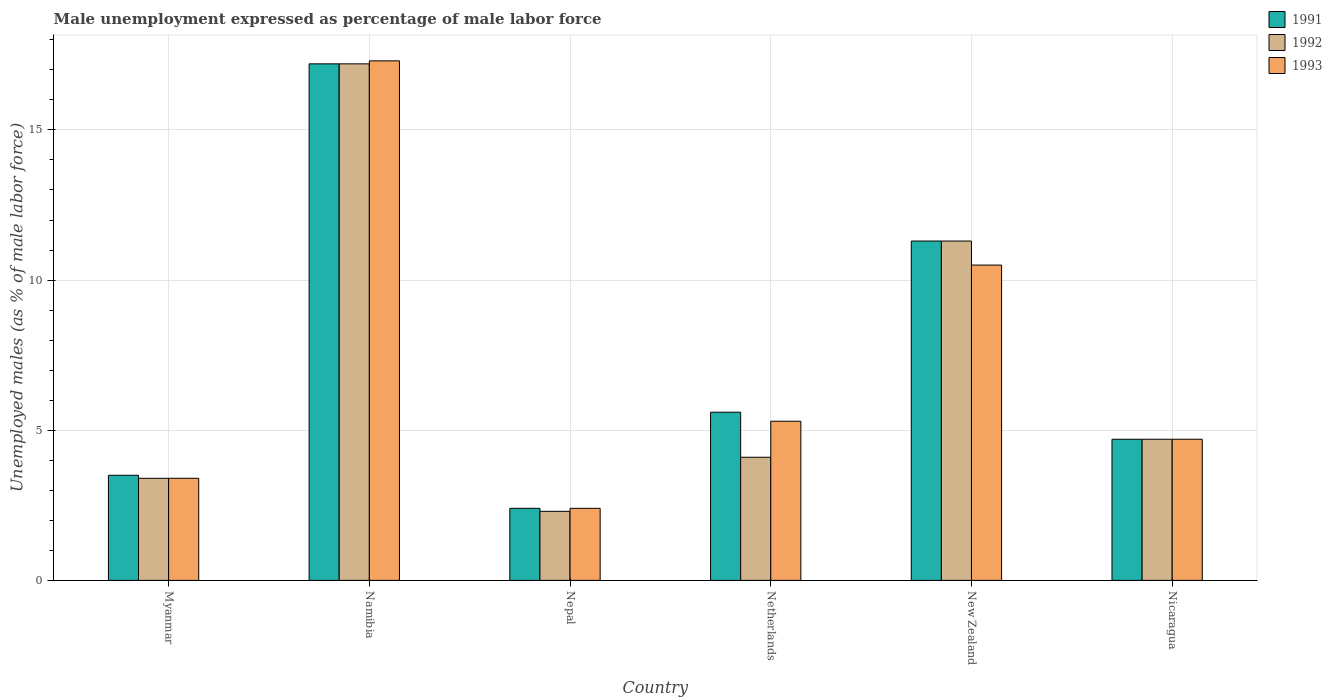How many different coloured bars are there?
Your answer should be compact. 3. How many groups of bars are there?
Ensure brevity in your answer.  6. Are the number of bars per tick equal to the number of legend labels?
Your response must be concise. Yes. Are the number of bars on each tick of the X-axis equal?
Offer a very short reply. Yes. How many bars are there on the 6th tick from the left?
Your answer should be very brief. 3. How many bars are there on the 4th tick from the right?
Provide a short and direct response. 3. What is the label of the 5th group of bars from the left?
Offer a terse response. New Zealand. In how many cases, is the number of bars for a given country not equal to the number of legend labels?
Your answer should be compact. 0. What is the unemployment in males in in 1992 in New Zealand?
Offer a terse response. 11.3. Across all countries, what is the maximum unemployment in males in in 1991?
Your answer should be very brief. 17.2. Across all countries, what is the minimum unemployment in males in in 1993?
Your response must be concise. 2.4. In which country was the unemployment in males in in 1993 maximum?
Ensure brevity in your answer.  Namibia. In which country was the unemployment in males in in 1992 minimum?
Make the answer very short. Nepal. What is the total unemployment in males in in 1992 in the graph?
Your answer should be very brief. 43. What is the difference between the unemployment in males in in 1993 in Myanmar and that in Nicaragua?
Ensure brevity in your answer.  -1.3. What is the difference between the unemployment in males in in 1991 in New Zealand and the unemployment in males in in 1993 in Netherlands?
Your response must be concise. 6. What is the average unemployment in males in in 1992 per country?
Your answer should be compact. 7.17. What is the difference between the unemployment in males in of/in 1992 and unemployment in males in of/in 1991 in Netherlands?
Offer a terse response. -1.5. What is the ratio of the unemployment in males in in 1992 in Myanmar to that in Netherlands?
Offer a terse response. 0.83. Is the difference between the unemployment in males in in 1992 in Namibia and Nicaragua greater than the difference between the unemployment in males in in 1991 in Namibia and Nicaragua?
Your response must be concise. No. What is the difference between the highest and the second highest unemployment in males in in 1993?
Your answer should be very brief. 6.8. What is the difference between the highest and the lowest unemployment in males in in 1992?
Keep it short and to the point. 14.9. Is the sum of the unemployment in males in in 1991 in New Zealand and Nicaragua greater than the maximum unemployment in males in in 1993 across all countries?
Give a very brief answer. No. What does the 2nd bar from the left in Nepal represents?
Ensure brevity in your answer.  1992. Is it the case that in every country, the sum of the unemployment in males in in 1991 and unemployment in males in in 1992 is greater than the unemployment in males in in 1993?
Your answer should be very brief. Yes. Are all the bars in the graph horizontal?
Offer a terse response. No. How many countries are there in the graph?
Ensure brevity in your answer.  6. What is the difference between two consecutive major ticks on the Y-axis?
Offer a very short reply. 5. Are the values on the major ticks of Y-axis written in scientific E-notation?
Offer a very short reply. No. How many legend labels are there?
Make the answer very short. 3. What is the title of the graph?
Make the answer very short. Male unemployment expressed as percentage of male labor force. Does "1963" appear as one of the legend labels in the graph?
Offer a terse response. No. What is the label or title of the X-axis?
Offer a terse response. Country. What is the label or title of the Y-axis?
Offer a very short reply. Unemployed males (as % of male labor force). What is the Unemployed males (as % of male labor force) of 1992 in Myanmar?
Your answer should be compact. 3.4. What is the Unemployed males (as % of male labor force) of 1993 in Myanmar?
Keep it short and to the point. 3.4. What is the Unemployed males (as % of male labor force) in 1991 in Namibia?
Keep it short and to the point. 17.2. What is the Unemployed males (as % of male labor force) of 1992 in Namibia?
Your answer should be very brief. 17.2. What is the Unemployed males (as % of male labor force) in 1993 in Namibia?
Make the answer very short. 17.3. What is the Unemployed males (as % of male labor force) of 1991 in Nepal?
Keep it short and to the point. 2.4. What is the Unemployed males (as % of male labor force) of 1992 in Nepal?
Ensure brevity in your answer.  2.3. What is the Unemployed males (as % of male labor force) of 1993 in Nepal?
Your answer should be compact. 2.4. What is the Unemployed males (as % of male labor force) in 1991 in Netherlands?
Offer a very short reply. 5.6. What is the Unemployed males (as % of male labor force) of 1992 in Netherlands?
Provide a succinct answer. 4.1. What is the Unemployed males (as % of male labor force) of 1993 in Netherlands?
Offer a terse response. 5.3. What is the Unemployed males (as % of male labor force) in 1991 in New Zealand?
Provide a short and direct response. 11.3. What is the Unemployed males (as % of male labor force) of 1992 in New Zealand?
Provide a succinct answer. 11.3. What is the Unemployed males (as % of male labor force) in 1993 in New Zealand?
Make the answer very short. 10.5. What is the Unemployed males (as % of male labor force) in 1991 in Nicaragua?
Offer a terse response. 4.7. What is the Unemployed males (as % of male labor force) of 1992 in Nicaragua?
Your answer should be very brief. 4.7. What is the Unemployed males (as % of male labor force) in 1993 in Nicaragua?
Keep it short and to the point. 4.7. Across all countries, what is the maximum Unemployed males (as % of male labor force) of 1991?
Make the answer very short. 17.2. Across all countries, what is the maximum Unemployed males (as % of male labor force) of 1992?
Give a very brief answer. 17.2. Across all countries, what is the maximum Unemployed males (as % of male labor force) in 1993?
Make the answer very short. 17.3. Across all countries, what is the minimum Unemployed males (as % of male labor force) of 1991?
Make the answer very short. 2.4. Across all countries, what is the minimum Unemployed males (as % of male labor force) in 1992?
Your answer should be compact. 2.3. Across all countries, what is the minimum Unemployed males (as % of male labor force) in 1993?
Provide a succinct answer. 2.4. What is the total Unemployed males (as % of male labor force) of 1991 in the graph?
Offer a terse response. 44.7. What is the total Unemployed males (as % of male labor force) in 1992 in the graph?
Make the answer very short. 43. What is the total Unemployed males (as % of male labor force) in 1993 in the graph?
Provide a short and direct response. 43.6. What is the difference between the Unemployed males (as % of male labor force) in 1991 in Myanmar and that in Namibia?
Give a very brief answer. -13.7. What is the difference between the Unemployed males (as % of male labor force) of 1992 in Myanmar and that in Namibia?
Your response must be concise. -13.8. What is the difference between the Unemployed males (as % of male labor force) of 1992 in Myanmar and that in Nepal?
Your answer should be compact. 1.1. What is the difference between the Unemployed males (as % of male labor force) in 1991 in Myanmar and that in Netherlands?
Your response must be concise. -2.1. What is the difference between the Unemployed males (as % of male labor force) of 1992 in Myanmar and that in Netherlands?
Offer a very short reply. -0.7. What is the difference between the Unemployed males (as % of male labor force) of 1991 in Myanmar and that in New Zealand?
Offer a terse response. -7.8. What is the difference between the Unemployed males (as % of male labor force) in 1992 in Myanmar and that in New Zealand?
Offer a terse response. -7.9. What is the difference between the Unemployed males (as % of male labor force) in 1993 in Myanmar and that in Nicaragua?
Your response must be concise. -1.3. What is the difference between the Unemployed males (as % of male labor force) in 1993 in Namibia and that in Nepal?
Your answer should be compact. 14.9. What is the difference between the Unemployed males (as % of male labor force) of 1992 in Namibia and that in Netherlands?
Offer a terse response. 13.1. What is the difference between the Unemployed males (as % of male labor force) of 1991 in Namibia and that in Nicaragua?
Make the answer very short. 12.5. What is the difference between the Unemployed males (as % of male labor force) of 1991 in Nepal and that in Netherlands?
Provide a succinct answer. -3.2. What is the difference between the Unemployed males (as % of male labor force) of 1992 in Nepal and that in Netherlands?
Offer a very short reply. -1.8. What is the difference between the Unemployed males (as % of male labor force) in 1993 in Nepal and that in Netherlands?
Your response must be concise. -2.9. What is the difference between the Unemployed males (as % of male labor force) in 1991 in Nepal and that in New Zealand?
Make the answer very short. -8.9. What is the difference between the Unemployed males (as % of male labor force) in 1991 in Nepal and that in Nicaragua?
Your answer should be very brief. -2.3. What is the difference between the Unemployed males (as % of male labor force) of 1992 in Nepal and that in Nicaragua?
Your answer should be very brief. -2.4. What is the difference between the Unemployed males (as % of male labor force) of 1992 in Netherlands and that in New Zealand?
Offer a terse response. -7.2. What is the difference between the Unemployed males (as % of male labor force) in 1993 in Netherlands and that in Nicaragua?
Your answer should be very brief. 0.6. What is the difference between the Unemployed males (as % of male labor force) in 1992 in New Zealand and that in Nicaragua?
Provide a short and direct response. 6.6. What is the difference between the Unemployed males (as % of male labor force) in 1991 in Myanmar and the Unemployed males (as % of male labor force) in 1992 in Namibia?
Provide a succinct answer. -13.7. What is the difference between the Unemployed males (as % of male labor force) of 1991 in Myanmar and the Unemployed males (as % of male labor force) of 1992 in Nepal?
Keep it short and to the point. 1.2. What is the difference between the Unemployed males (as % of male labor force) of 1991 in Myanmar and the Unemployed males (as % of male labor force) of 1993 in Nepal?
Keep it short and to the point. 1.1. What is the difference between the Unemployed males (as % of male labor force) of 1991 in Myanmar and the Unemployed males (as % of male labor force) of 1992 in Netherlands?
Your response must be concise. -0.6. What is the difference between the Unemployed males (as % of male labor force) in 1992 in Myanmar and the Unemployed males (as % of male labor force) in 1993 in Netherlands?
Provide a succinct answer. -1.9. What is the difference between the Unemployed males (as % of male labor force) in 1991 in Myanmar and the Unemployed males (as % of male labor force) in 1992 in New Zealand?
Give a very brief answer. -7.8. What is the difference between the Unemployed males (as % of male labor force) of 1992 in Myanmar and the Unemployed males (as % of male labor force) of 1993 in Nicaragua?
Provide a succinct answer. -1.3. What is the difference between the Unemployed males (as % of male labor force) of 1991 in Namibia and the Unemployed males (as % of male labor force) of 1992 in Nepal?
Provide a short and direct response. 14.9. What is the difference between the Unemployed males (as % of male labor force) of 1991 in Namibia and the Unemployed males (as % of male labor force) of 1993 in Netherlands?
Provide a succinct answer. 11.9. What is the difference between the Unemployed males (as % of male labor force) in 1992 in Namibia and the Unemployed males (as % of male labor force) in 1993 in Netherlands?
Offer a terse response. 11.9. What is the difference between the Unemployed males (as % of male labor force) of 1991 in Namibia and the Unemployed males (as % of male labor force) of 1992 in New Zealand?
Offer a terse response. 5.9. What is the difference between the Unemployed males (as % of male labor force) of 1991 in Namibia and the Unemployed males (as % of male labor force) of 1993 in New Zealand?
Keep it short and to the point. 6.7. What is the difference between the Unemployed males (as % of male labor force) of 1991 in Namibia and the Unemployed males (as % of male labor force) of 1992 in Nicaragua?
Offer a terse response. 12.5. What is the difference between the Unemployed males (as % of male labor force) in 1991 in Namibia and the Unemployed males (as % of male labor force) in 1993 in Nicaragua?
Ensure brevity in your answer.  12.5. What is the difference between the Unemployed males (as % of male labor force) in 1992 in Nepal and the Unemployed males (as % of male labor force) in 1993 in Netherlands?
Provide a succinct answer. -3. What is the difference between the Unemployed males (as % of male labor force) in 1991 in Nepal and the Unemployed males (as % of male labor force) in 1993 in New Zealand?
Provide a short and direct response. -8.1. What is the difference between the Unemployed males (as % of male labor force) of 1991 in Nepal and the Unemployed males (as % of male labor force) of 1993 in Nicaragua?
Your response must be concise. -2.3. What is the difference between the Unemployed males (as % of male labor force) of 1992 in Netherlands and the Unemployed males (as % of male labor force) of 1993 in New Zealand?
Make the answer very short. -6.4. What is the difference between the Unemployed males (as % of male labor force) of 1992 in Netherlands and the Unemployed males (as % of male labor force) of 1993 in Nicaragua?
Ensure brevity in your answer.  -0.6. What is the difference between the Unemployed males (as % of male labor force) in 1992 in New Zealand and the Unemployed males (as % of male labor force) in 1993 in Nicaragua?
Ensure brevity in your answer.  6.6. What is the average Unemployed males (as % of male labor force) of 1991 per country?
Offer a terse response. 7.45. What is the average Unemployed males (as % of male labor force) in 1992 per country?
Your answer should be compact. 7.17. What is the average Unemployed males (as % of male labor force) of 1993 per country?
Offer a very short reply. 7.27. What is the difference between the Unemployed males (as % of male labor force) of 1991 and Unemployed males (as % of male labor force) of 1993 in Namibia?
Your answer should be compact. -0.1. What is the difference between the Unemployed males (as % of male labor force) in 1992 and Unemployed males (as % of male labor force) in 1993 in Namibia?
Keep it short and to the point. -0.1. What is the difference between the Unemployed males (as % of male labor force) of 1991 and Unemployed males (as % of male labor force) of 1992 in Nepal?
Your answer should be very brief. 0.1. What is the difference between the Unemployed males (as % of male labor force) of 1992 and Unemployed males (as % of male labor force) of 1993 in Nepal?
Your response must be concise. -0.1. What is the difference between the Unemployed males (as % of male labor force) of 1991 and Unemployed males (as % of male labor force) of 1992 in Netherlands?
Ensure brevity in your answer.  1.5. What is the difference between the Unemployed males (as % of male labor force) in 1991 and Unemployed males (as % of male labor force) in 1993 in Netherlands?
Offer a terse response. 0.3. What is the difference between the Unemployed males (as % of male labor force) of 1991 and Unemployed males (as % of male labor force) of 1992 in New Zealand?
Make the answer very short. 0. What is the difference between the Unemployed males (as % of male labor force) in 1991 and Unemployed males (as % of male labor force) in 1993 in New Zealand?
Offer a very short reply. 0.8. What is the difference between the Unemployed males (as % of male labor force) of 1992 and Unemployed males (as % of male labor force) of 1993 in New Zealand?
Offer a very short reply. 0.8. What is the ratio of the Unemployed males (as % of male labor force) in 1991 in Myanmar to that in Namibia?
Offer a very short reply. 0.2. What is the ratio of the Unemployed males (as % of male labor force) of 1992 in Myanmar to that in Namibia?
Keep it short and to the point. 0.2. What is the ratio of the Unemployed males (as % of male labor force) in 1993 in Myanmar to that in Namibia?
Your response must be concise. 0.2. What is the ratio of the Unemployed males (as % of male labor force) of 1991 in Myanmar to that in Nepal?
Your answer should be very brief. 1.46. What is the ratio of the Unemployed males (as % of male labor force) of 1992 in Myanmar to that in Nepal?
Your answer should be compact. 1.48. What is the ratio of the Unemployed males (as % of male labor force) in 1993 in Myanmar to that in Nepal?
Your response must be concise. 1.42. What is the ratio of the Unemployed males (as % of male labor force) in 1991 in Myanmar to that in Netherlands?
Your answer should be very brief. 0.62. What is the ratio of the Unemployed males (as % of male labor force) of 1992 in Myanmar to that in Netherlands?
Keep it short and to the point. 0.83. What is the ratio of the Unemployed males (as % of male labor force) of 1993 in Myanmar to that in Netherlands?
Make the answer very short. 0.64. What is the ratio of the Unemployed males (as % of male labor force) in 1991 in Myanmar to that in New Zealand?
Your response must be concise. 0.31. What is the ratio of the Unemployed males (as % of male labor force) in 1992 in Myanmar to that in New Zealand?
Keep it short and to the point. 0.3. What is the ratio of the Unemployed males (as % of male labor force) in 1993 in Myanmar to that in New Zealand?
Provide a succinct answer. 0.32. What is the ratio of the Unemployed males (as % of male labor force) of 1991 in Myanmar to that in Nicaragua?
Provide a short and direct response. 0.74. What is the ratio of the Unemployed males (as % of male labor force) of 1992 in Myanmar to that in Nicaragua?
Provide a succinct answer. 0.72. What is the ratio of the Unemployed males (as % of male labor force) in 1993 in Myanmar to that in Nicaragua?
Your answer should be compact. 0.72. What is the ratio of the Unemployed males (as % of male labor force) of 1991 in Namibia to that in Nepal?
Provide a short and direct response. 7.17. What is the ratio of the Unemployed males (as % of male labor force) in 1992 in Namibia to that in Nepal?
Give a very brief answer. 7.48. What is the ratio of the Unemployed males (as % of male labor force) of 1993 in Namibia to that in Nepal?
Your response must be concise. 7.21. What is the ratio of the Unemployed males (as % of male labor force) of 1991 in Namibia to that in Netherlands?
Your answer should be compact. 3.07. What is the ratio of the Unemployed males (as % of male labor force) of 1992 in Namibia to that in Netherlands?
Offer a terse response. 4.2. What is the ratio of the Unemployed males (as % of male labor force) in 1993 in Namibia to that in Netherlands?
Your answer should be compact. 3.26. What is the ratio of the Unemployed males (as % of male labor force) in 1991 in Namibia to that in New Zealand?
Your response must be concise. 1.52. What is the ratio of the Unemployed males (as % of male labor force) in 1992 in Namibia to that in New Zealand?
Your answer should be compact. 1.52. What is the ratio of the Unemployed males (as % of male labor force) of 1993 in Namibia to that in New Zealand?
Offer a very short reply. 1.65. What is the ratio of the Unemployed males (as % of male labor force) in 1991 in Namibia to that in Nicaragua?
Provide a short and direct response. 3.66. What is the ratio of the Unemployed males (as % of male labor force) in 1992 in Namibia to that in Nicaragua?
Ensure brevity in your answer.  3.66. What is the ratio of the Unemployed males (as % of male labor force) in 1993 in Namibia to that in Nicaragua?
Make the answer very short. 3.68. What is the ratio of the Unemployed males (as % of male labor force) of 1991 in Nepal to that in Netherlands?
Make the answer very short. 0.43. What is the ratio of the Unemployed males (as % of male labor force) in 1992 in Nepal to that in Netherlands?
Provide a succinct answer. 0.56. What is the ratio of the Unemployed males (as % of male labor force) in 1993 in Nepal to that in Netherlands?
Offer a very short reply. 0.45. What is the ratio of the Unemployed males (as % of male labor force) in 1991 in Nepal to that in New Zealand?
Make the answer very short. 0.21. What is the ratio of the Unemployed males (as % of male labor force) of 1992 in Nepal to that in New Zealand?
Ensure brevity in your answer.  0.2. What is the ratio of the Unemployed males (as % of male labor force) of 1993 in Nepal to that in New Zealand?
Make the answer very short. 0.23. What is the ratio of the Unemployed males (as % of male labor force) of 1991 in Nepal to that in Nicaragua?
Your answer should be compact. 0.51. What is the ratio of the Unemployed males (as % of male labor force) in 1992 in Nepal to that in Nicaragua?
Your answer should be very brief. 0.49. What is the ratio of the Unemployed males (as % of male labor force) of 1993 in Nepal to that in Nicaragua?
Your answer should be compact. 0.51. What is the ratio of the Unemployed males (as % of male labor force) of 1991 in Netherlands to that in New Zealand?
Ensure brevity in your answer.  0.5. What is the ratio of the Unemployed males (as % of male labor force) of 1992 in Netherlands to that in New Zealand?
Provide a succinct answer. 0.36. What is the ratio of the Unemployed males (as % of male labor force) of 1993 in Netherlands to that in New Zealand?
Offer a very short reply. 0.5. What is the ratio of the Unemployed males (as % of male labor force) of 1991 in Netherlands to that in Nicaragua?
Your answer should be compact. 1.19. What is the ratio of the Unemployed males (as % of male labor force) of 1992 in Netherlands to that in Nicaragua?
Your answer should be compact. 0.87. What is the ratio of the Unemployed males (as % of male labor force) of 1993 in Netherlands to that in Nicaragua?
Provide a short and direct response. 1.13. What is the ratio of the Unemployed males (as % of male labor force) in 1991 in New Zealand to that in Nicaragua?
Ensure brevity in your answer.  2.4. What is the ratio of the Unemployed males (as % of male labor force) of 1992 in New Zealand to that in Nicaragua?
Ensure brevity in your answer.  2.4. What is the ratio of the Unemployed males (as % of male labor force) in 1993 in New Zealand to that in Nicaragua?
Make the answer very short. 2.23. What is the difference between the highest and the second highest Unemployed males (as % of male labor force) in 1992?
Make the answer very short. 5.9. 